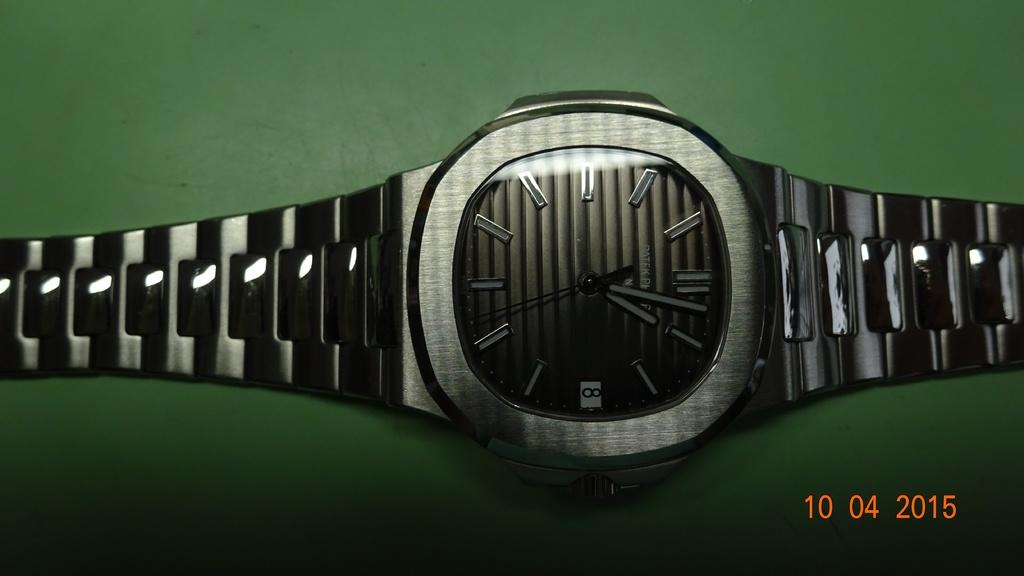Provide a one-sentence caption for the provided image. A picture of a silver watch with grayish black face with the tine 1:02 laying on a green background. 